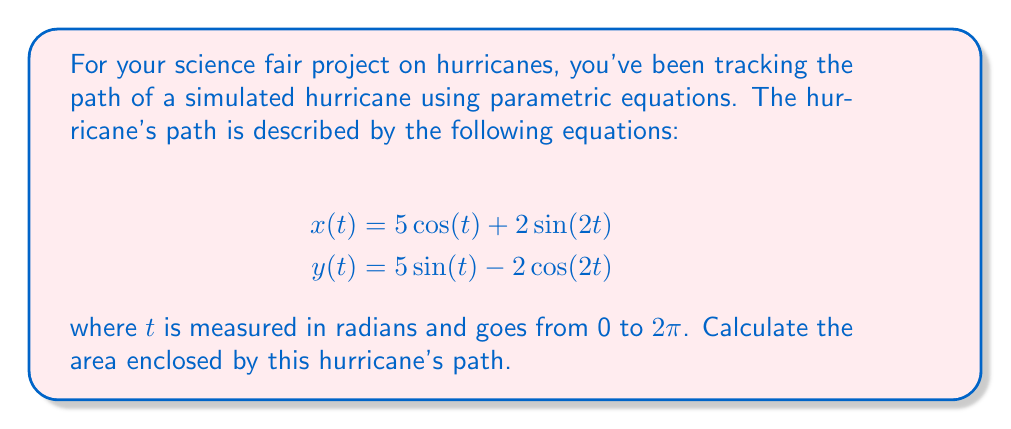Show me your answer to this math problem. To find the area enclosed by a parametric curve, we can use Green's theorem, which states that the area is given by:

$$ A = \frac{1}{2} \int_0^{2\pi} [x(t)y'(t) - y(t)x'(t)] dt $$

Let's follow these steps:

1) First, we need to find $x'(t)$ and $y'(t)$:
   $x'(t) = -5\sin(t) + 4\cos(2t)$
   $y'(t) = 5\cos(t) + 4\sin(2t)$

2) Now, let's substitute these into our area formula:

   $$ A = \frac{1}{2} \int_0^{2\pi} [(5\cos(t) + 2\sin(2t))(5\cos(t) + 4\sin(2t)) - $$
   $$ (5\sin(t) - 2\cos(2t))(-5\sin(t) + 4\cos(2t))] dt $$

3) Expand this expression:

   $$ A = \frac{1}{2} \int_0^{2\pi} [25\cos^2(t) + 20\cos(t)\sin(2t) + 10\sin(2t)\cos(t) + 8\sin^2(2t) + $$
   $$ 25\sin^2(t) - 20\sin(t)\cos(2t) - 10\cos(2t)\sin(t) + 8\cos^2(2t)] dt $$

4) Simplify using trigonometric identities:
   $\cos^2(t) + \sin^2(t) = 1$
   $\sin(2t) = 2\sin(t)\cos(t)$
   $\cos(2t) = \cos^2(t) - \sin^2(t)$

   After simplification, many terms cancel out, leaving us with:

   $$ A = \frac{1}{2} \int_0^{2\pi} [25 + 8] dt = \frac{33}{2} \int_0^{2\pi} dt $$

5) Evaluate the integral:

   $$ A = \frac{33}{2} [t]_0^{2\pi} = \frac{33}{2} (2\pi) = 33\pi $$

Therefore, the area enclosed by the hurricane's path is $33\pi$ square units.
Answer: $33\pi$ square units 